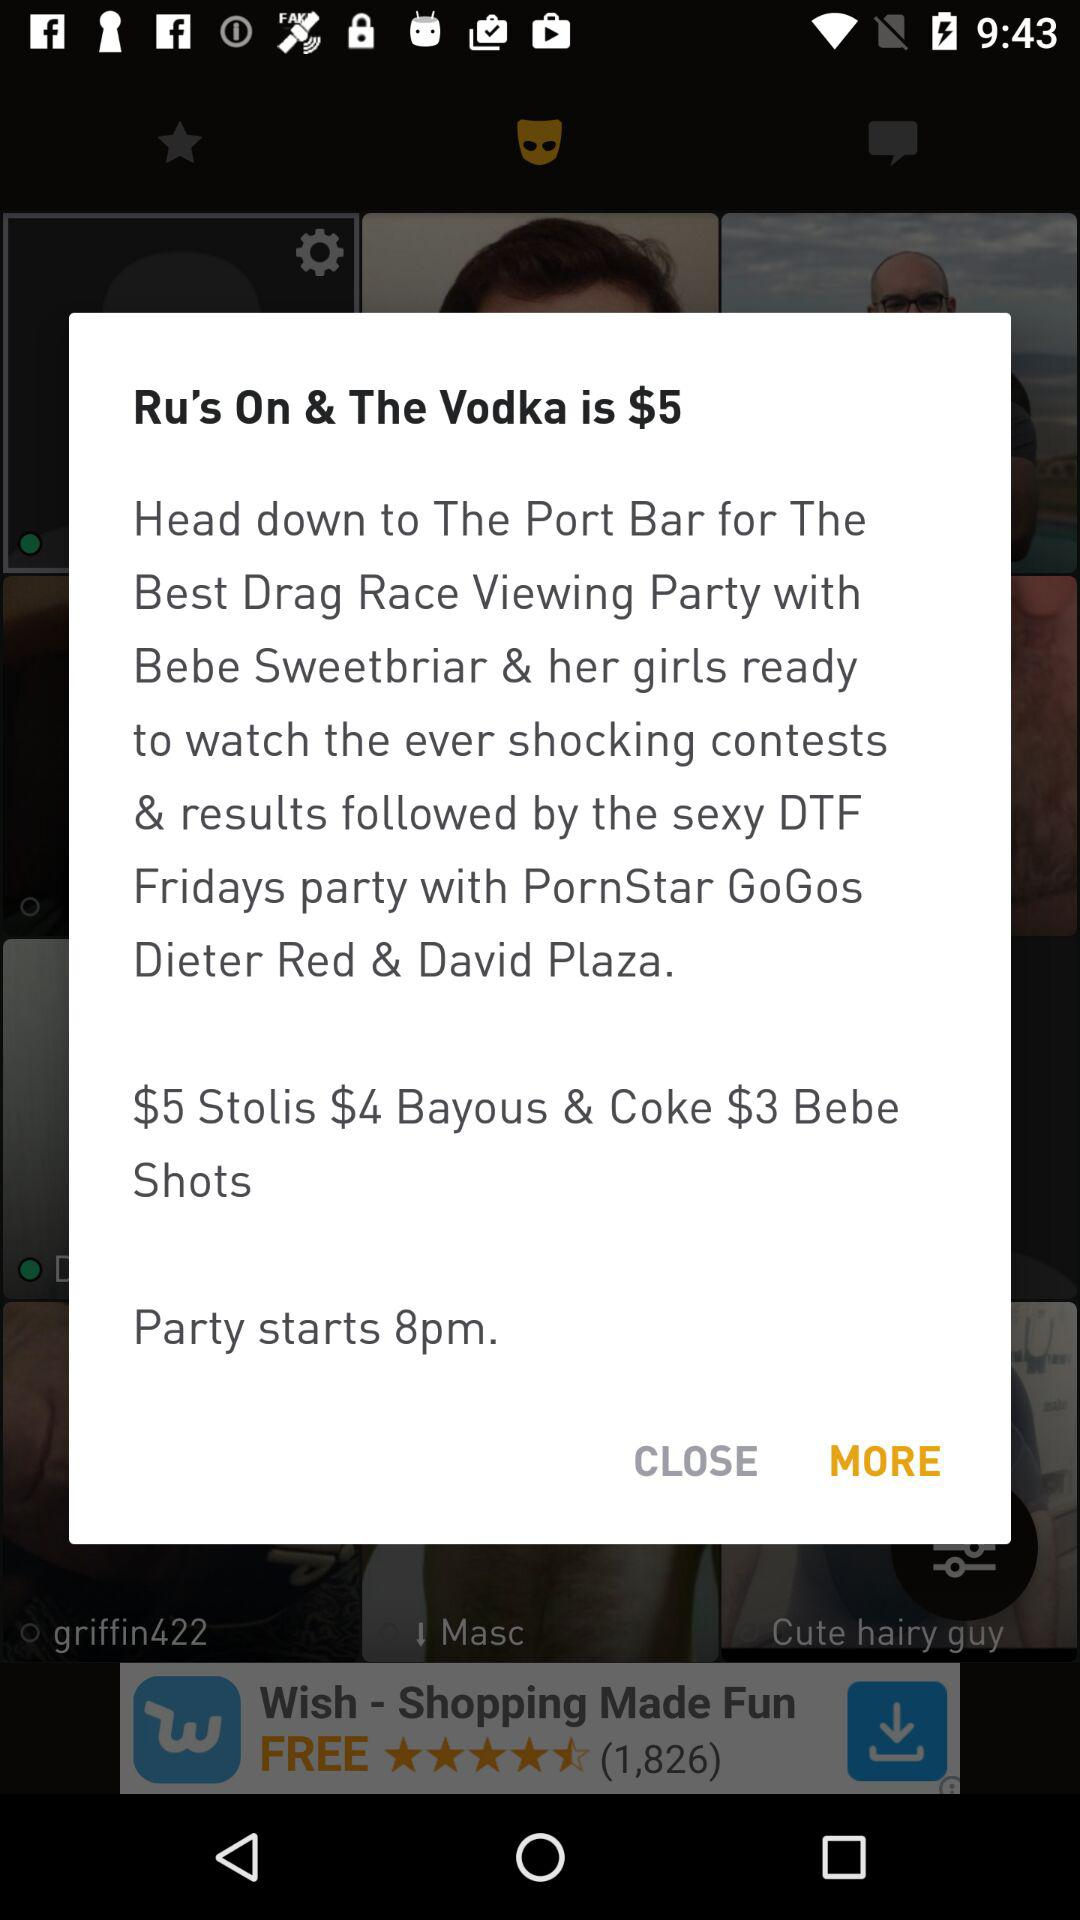When will the party start? The party will start at 8 p.m. 